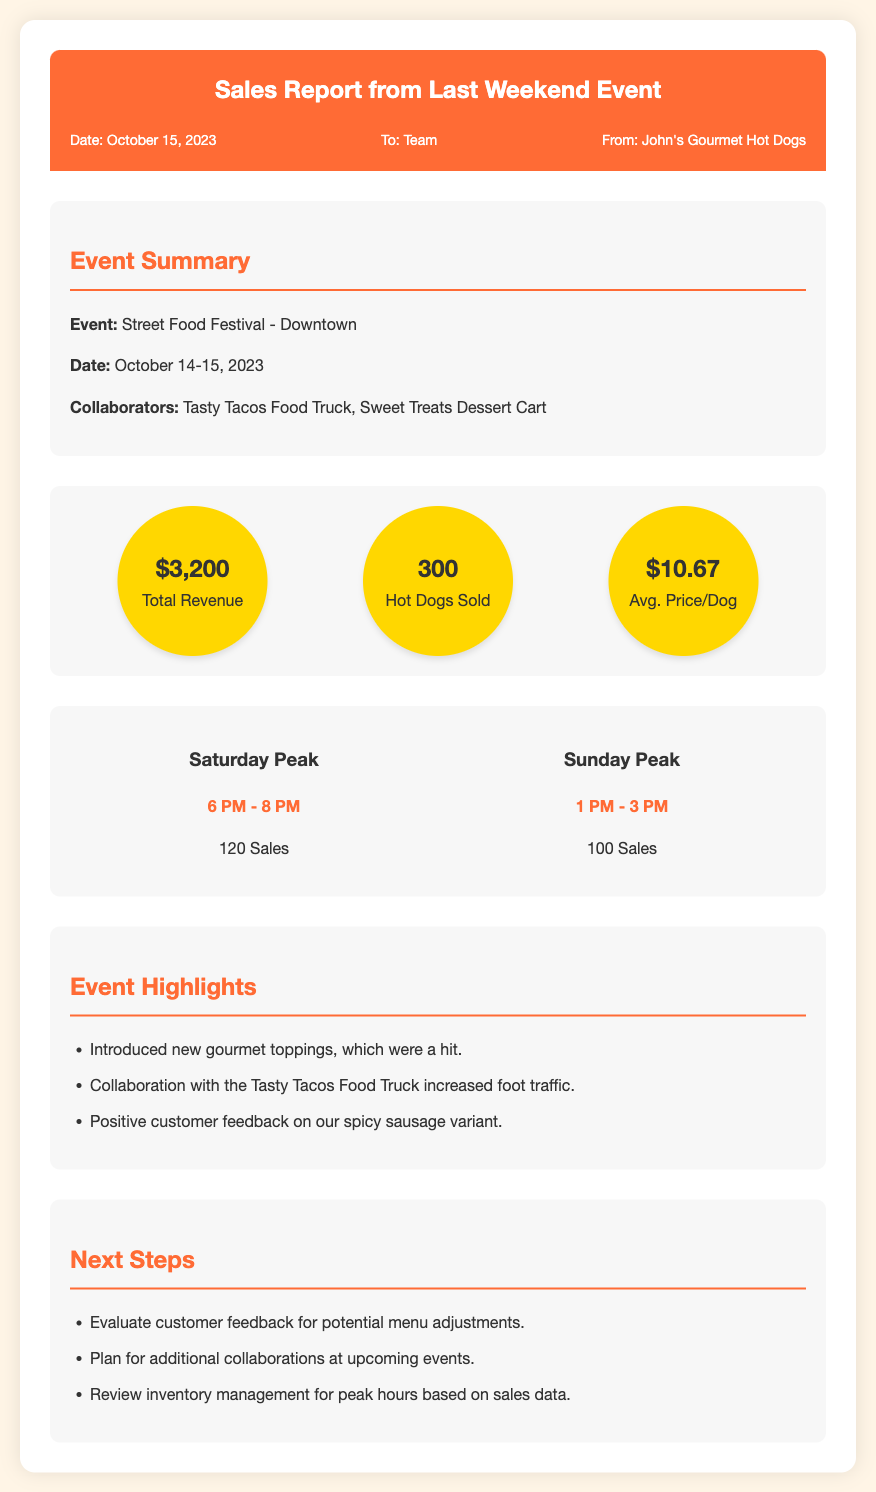What is the total revenue? The total revenue is provided in the sales data section of the memo.
Answer: $3,200 How many hot dogs were sold? The number of hot dogs sold is explicitly listed in the sales data section.
Answer: 300 What was the average price per hot dog? The average price per hot dog can be found in the sales data section of the memo.
Answer: $10.67 What were the peak sales hours on Saturday? The peak sales hours for Saturday is mentioned under the peak hours section.
Answer: 6 PM - 8 PM How many sales were made during the peak hours on Sunday? The sales made during peak hours on Sunday is provided in the peak hours section of the memo.
Answer: 100 What event was the report for? The event name is specified at the start of the summary section.
Answer: Street Food Festival - Downtown Who collaborated with John's Gourmet Hot Dogs at the event? The collaborators are listed in the event summary section of the memo.
Answer: Tasty Tacos Food Truck, Sweet Treats Dessert Cart What are one of the event highlights mentioned? One of the highlights is mentioned in the highlights section of the memo.
Answer: Introduced new gourmet toppings, which were a hit What is one of the next steps after the event? The next steps are discussed in the next steps section of the memo.
Answer: Evaluate customer feedback for potential menu adjustments 